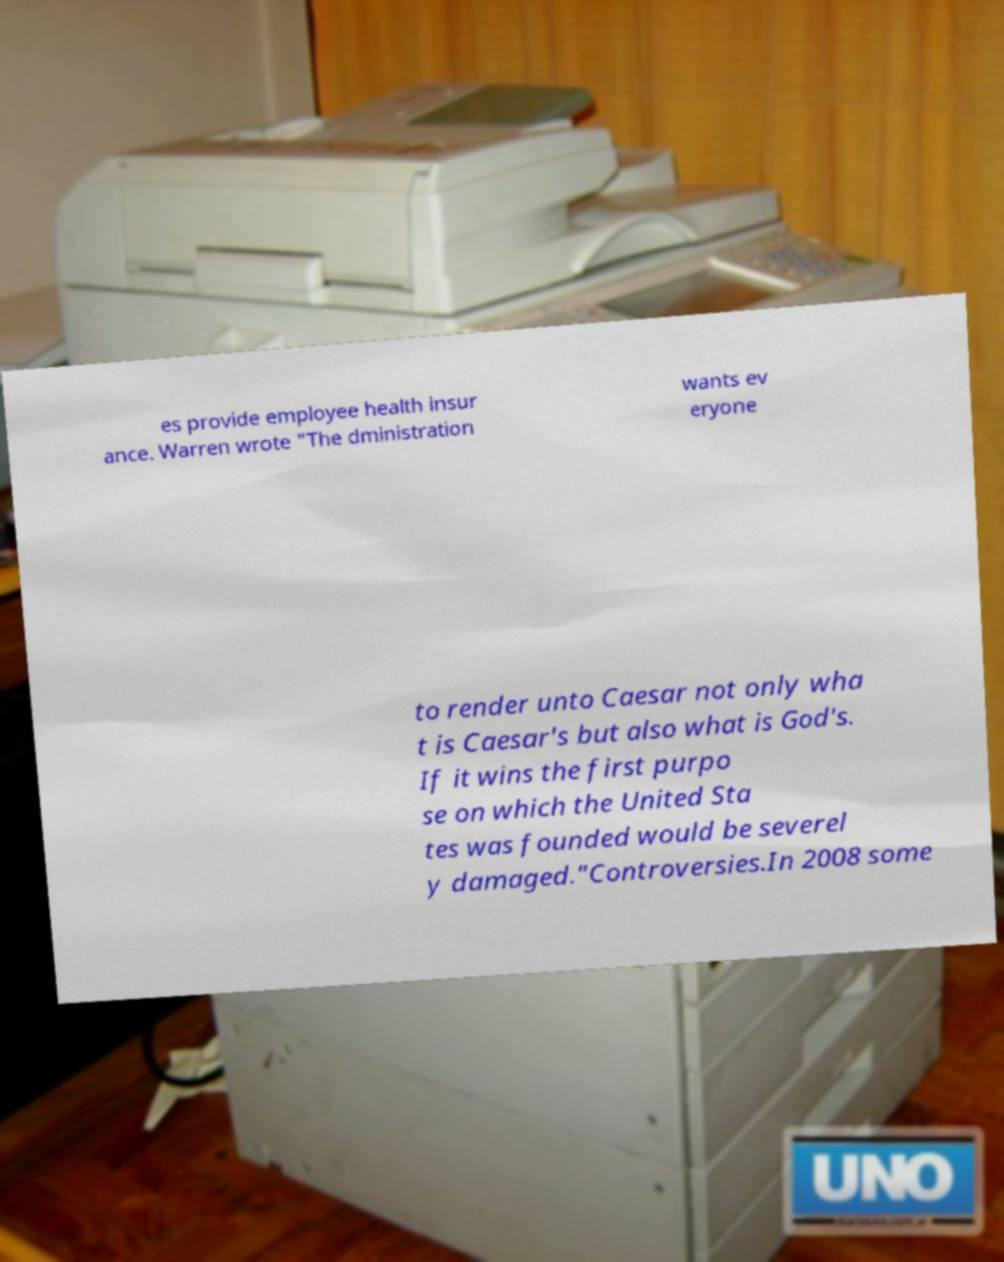Can you accurately transcribe the text from the provided image for me? es provide employee health insur ance. Warren wrote "The dministration wants ev eryone to render unto Caesar not only wha t is Caesar's but also what is God's. If it wins the first purpo se on which the United Sta tes was founded would be severel y damaged."Controversies.In 2008 some 